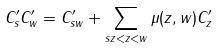<formula> <loc_0><loc_0><loc_500><loc_500>C _ { s } ^ { \prime } C _ { w } ^ { \prime } = C _ { s w } ^ { \prime } + \sum _ { s z < z < w } \mu ( z , w ) C _ { z } ^ { \prime }</formula> 